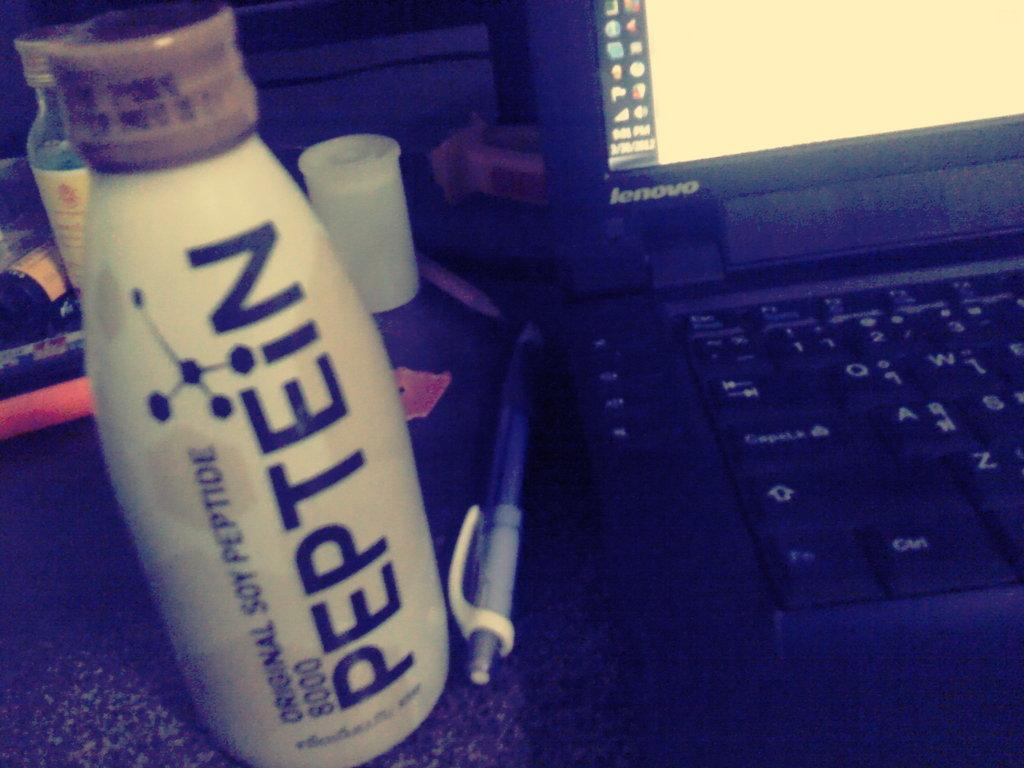<image>
Present a compact description of the photo's key features. Bottle of Peptein original soy peptide 8000 drink. 